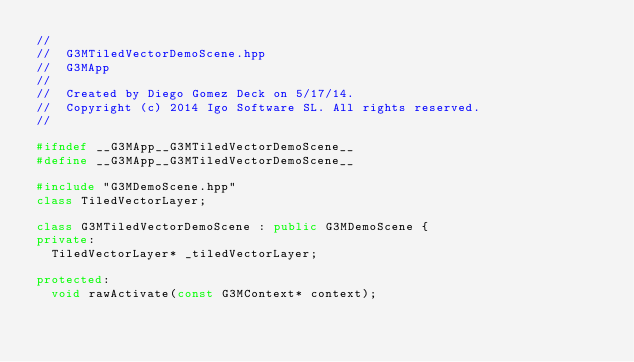<code> <loc_0><loc_0><loc_500><loc_500><_C++_>//
//  G3MTiledVectorDemoScene.hpp
//  G3MApp
//
//  Created by Diego Gomez Deck on 5/17/14.
//  Copyright (c) 2014 Igo Software SL. All rights reserved.
//

#ifndef __G3MApp__G3MTiledVectorDemoScene__
#define __G3MApp__G3MTiledVectorDemoScene__

#include "G3MDemoScene.hpp"
class TiledVectorLayer;

class G3MTiledVectorDemoScene : public G3MDemoScene {
private:
  TiledVectorLayer* _tiledVectorLayer;

protected:
  void rawActivate(const G3MContext* context);
</code> 